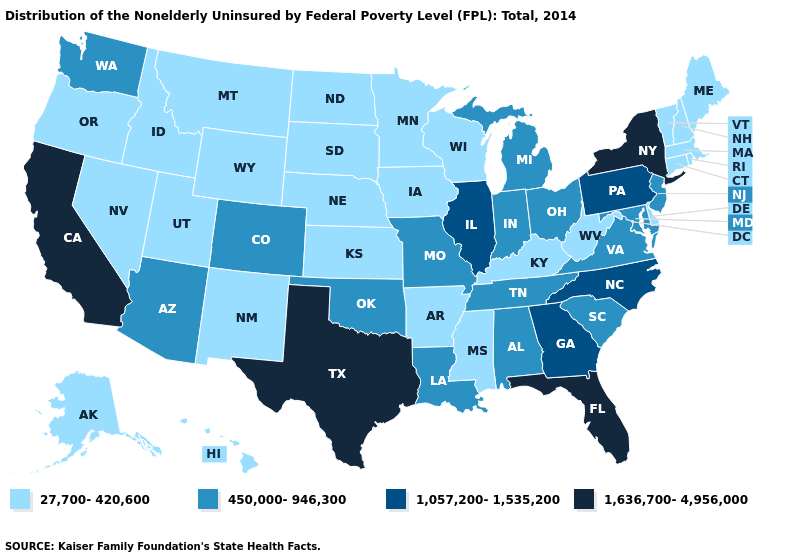Among the states that border Utah , which have the highest value?
Give a very brief answer. Arizona, Colorado. Among the states that border Connecticut , which have the highest value?
Be succinct. New York. Does the first symbol in the legend represent the smallest category?
Answer briefly. Yes. Does Georgia have a higher value than Wyoming?
Concise answer only. Yes. Name the states that have a value in the range 27,700-420,600?
Quick response, please. Alaska, Arkansas, Connecticut, Delaware, Hawaii, Idaho, Iowa, Kansas, Kentucky, Maine, Massachusetts, Minnesota, Mississippi, Montana, Nebraska, Nevada, New Hampshire, New Mexico, North Dakota, Oregon, Rhode Island, South Dakota, Utah, Vermont, West Virginia, Wisconsin, Wyoming. What is the value of New Mexico?
Short answer required. 27,700-420,600. Name the states that have a value in the range 1,636,700-4,956,000?
Write a very short answer. California, Florida, New York, Texas. Does Wyoming have a lower value than Massachusetts?
Give a very brief answer. No. What is the highest value in states that border Mississippi?
Quick response, please. 450,000-946,300. Does Missouri have the highest value in the USA?
Quick response, please. No. Name the states that have a value in the range 450,000-946,300?
Answer briefly. Alabama, Arizona, Colorado, Indiana, Louisiana, Maryland, Michigan, Missouri, New Jersey, Ohio, Oklahoma, South Carolina, Tennessee, Virginia, Washington. What is the highest value in the USA?
Short answer required. 1,636,700-4,956,000. How many symbols are there in the legend?
Concise answer only. 4. Among the states that border North Carolina , which have the lowest value?
Answer briefly. South Carolina, Tennessee, Virginia. 